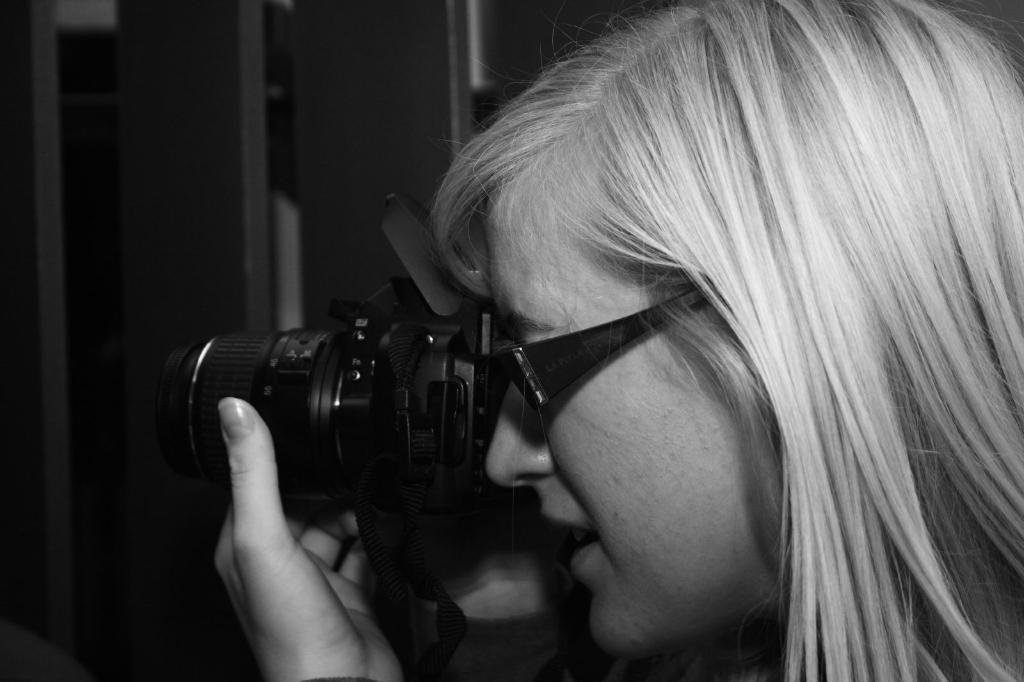Who is the main subject in the image? There is a woman in the image. What is the woman wearing that is visible in the image? The woman is wearing glasses (specs) in the image. What is the woman holding in the image? The woman is holding a camera in the image. What is the woman doing with the camera? The woman is taking a picture with the camera in the image. What time is it at the airport in the image? There is no airport present in the image, and the time is not mentioned or visible. 